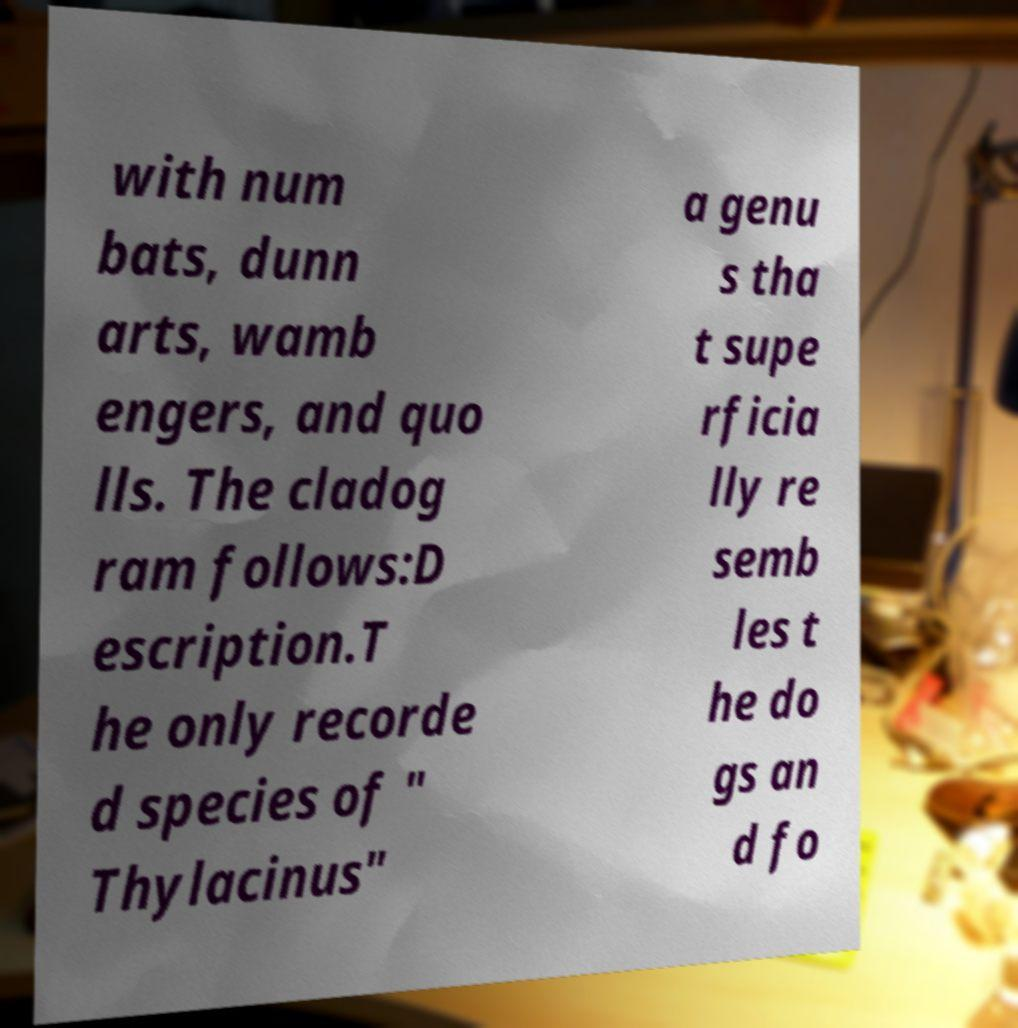Please identify and transcribe the text found in this image. with num bats, dunn arts, wamb engers, and quo lls. The cladog ram follows:D escription.T he only recorde d species of " Thylacinus" a genu s tha t supe rficia lly re semb les t he do gs an d fo 